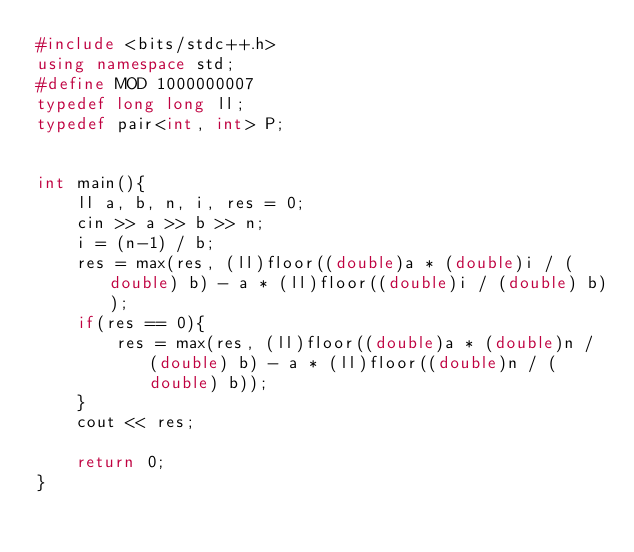<code> <loc_0><loc_0><loc_500><loc_500><_C++_>#include <bits/stdc++.h>
using namespace std;
#define MOD 1000000007
typedef long long ll;
typedef pair<int, int> P;


int main(){
    ll a, b, n, i, res = 0;
    cin >> a >> b >> n;
    i = (n-1) / b;
    res = max(res, (ll)floor((double)a * (double)i / (double) b) - a * (ll)floor((double)i / (double) b));
    if(res == 0){
        res = max(res, (ll)floor((double)a * (double)n / (double) b) - a * (ll)floor((double)n / (double) b));
    }
    cout << res;
    
    return 0;
}</code> 